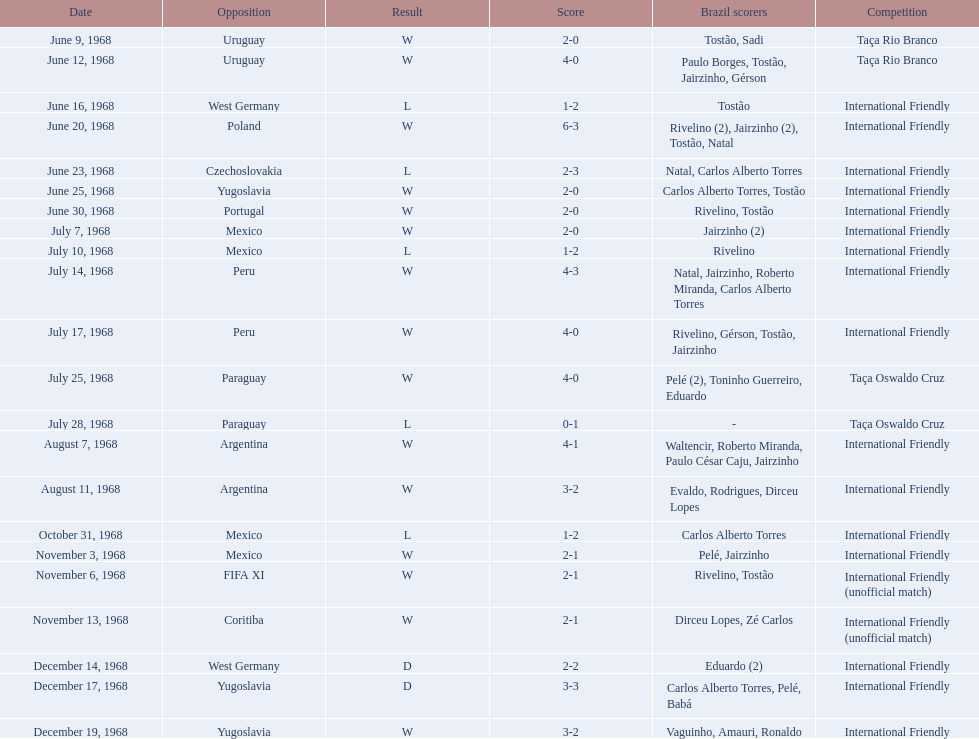How many instances did brazil score during the event on november 6th? 2. 